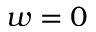Convert formula to latex. <formula><loc_0><loc_0><loc_500><loc_500>w = 0</formula> 